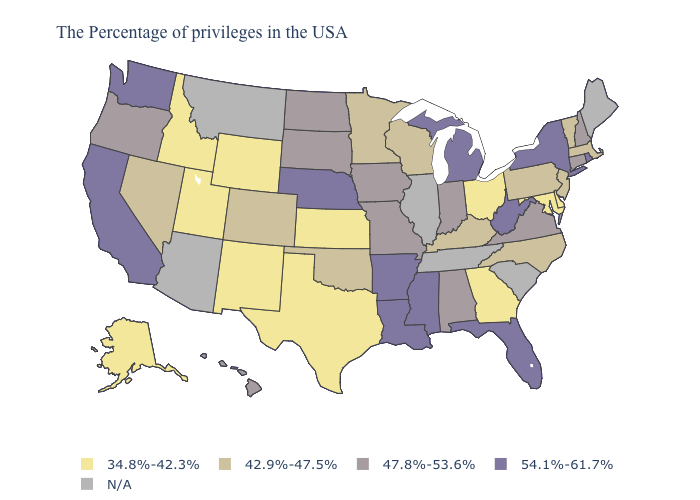Name the states that have a value in the range 47.8%-53.6%?
Give a very brief answer. New Hampshire, Connecticut, Virginia, Indiana, Alabama, Missouri, Iowa, South Dakota, North Dakota, Oregon, Hawaii. Does the first symbol in the legend represent the smallest category?
Short answer required. Yes. Name the states that have a value in the range 34.8%-42.3%?
Answer briefly. Delaware, Maryland, Ohio, Georgia, Kansas, Texas, Wyoming, New Mexico, Utah, Idaho, Alaska. What is the value of Arkansas?
Be succinct. 54.1%-61.7%. How many symbols are there in the legend?
Answer briefly. 5. Name the states that have a value in the range N/A?
Give a very brief answer. Maine, South Carolina, Tennessee, Illinois, Montana, Arizona. Among the states that border Alabama , which have the highest value?
Be succinct. Florida, Mississippi. What is the value of Massachusetts?
Give a very brief answer. 42.9%-47.5%. What is the value of Tennessee?
Give a very brief answer. N/A. Among the states that border Nevada , which have the highest value?
Write a very short answer. California. Name the states that have a value in the range 34.8%-42.3%?
Write a very short answer. Delaware, Maryland, Ohio, Georgia, Kansas, Texas, Wyoming, New Mexico, Utah, Idaho, Alaska. What is the value of Mississippi?
Give a very brief answer. 54.1%-61.7%. Among the states that border Michigan , does Indiana have the lowest value?
Concise answer only. No. Does New Hampshire have the highest value in the Northeast?
Write a very short answer. No. What is the value of Kentucky?
Give a very brief answer. 42.9%-47.5%. 